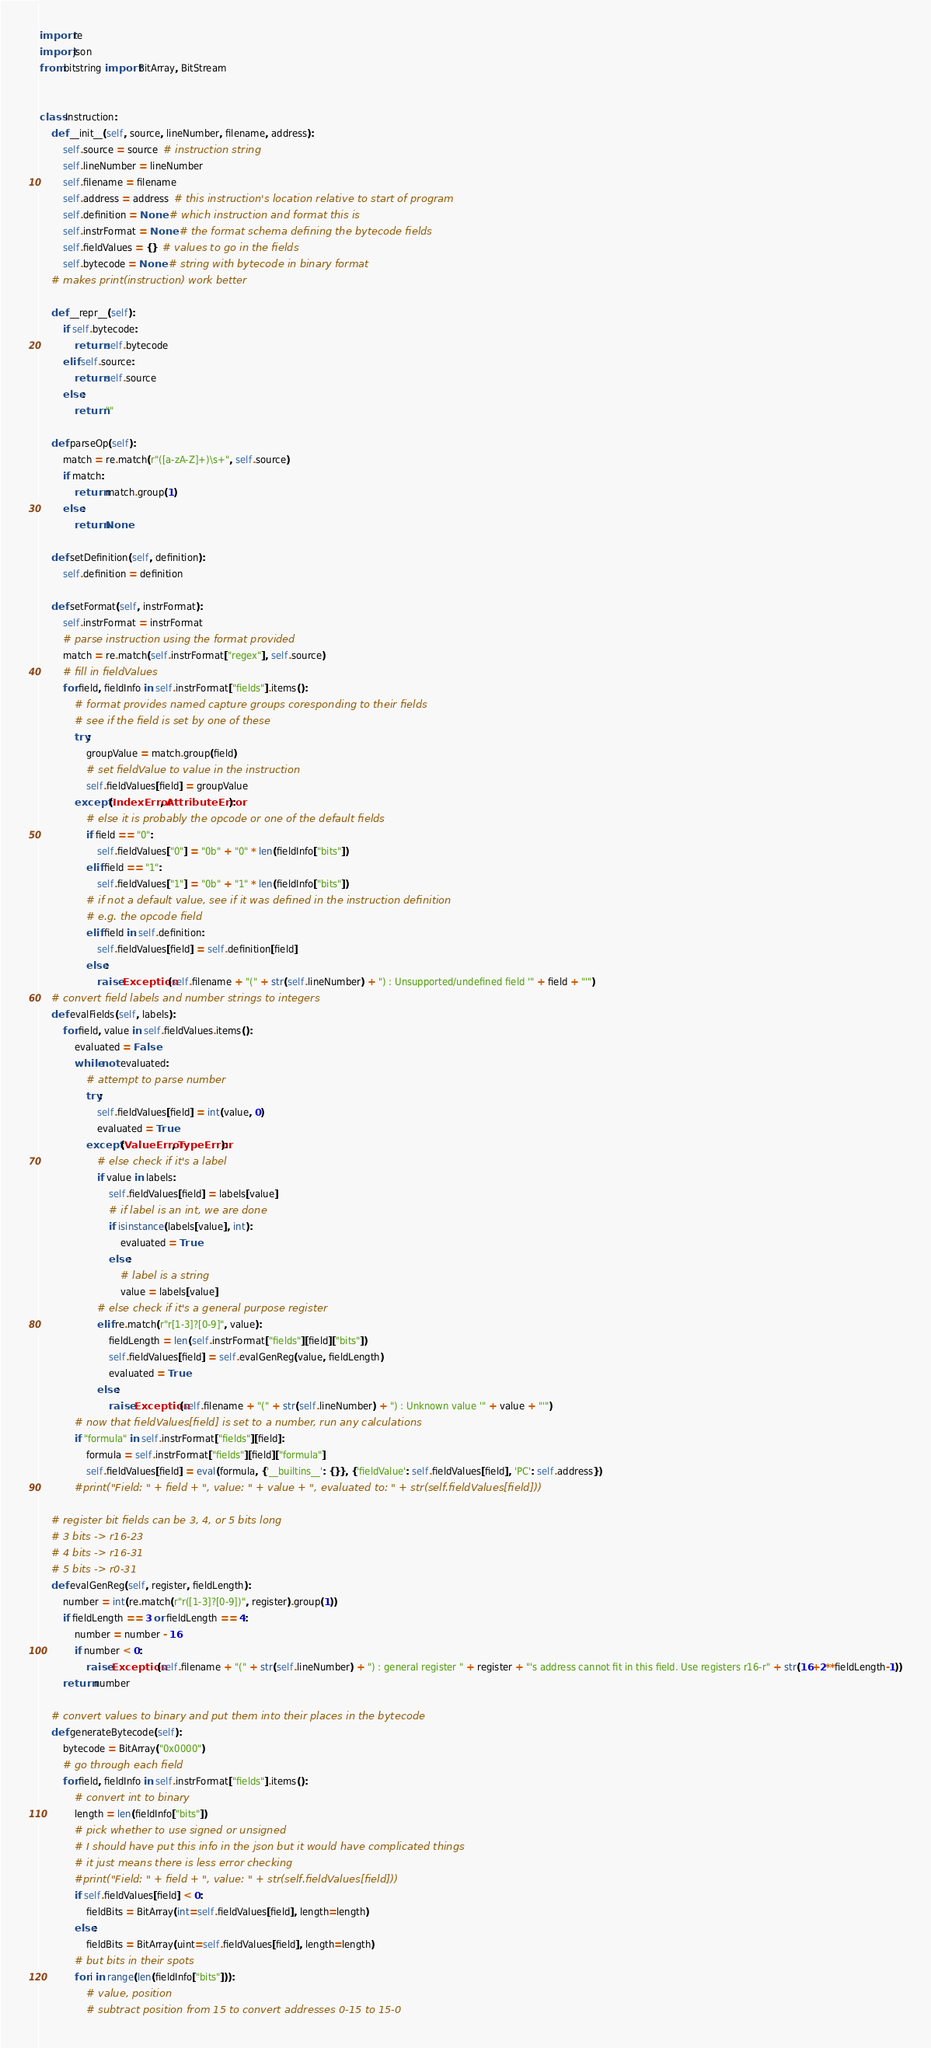<code> <loc_0><loc_0><loc_500><loc_500><_Python_>import re
import json
from bitstring import BitArray, BitStream


class Instruction:
    def __init__(self, source, lineNumber, filename, address):
        self.source = source  # instruction string
        self.lineNumber = lineNumber
        self.filename = filename
        self.address = address  # this instruction's location relative to start of program
        self.definition = None  # which instruction and format this is
        self.instrFormat = None  # the format schema defining the bytecode fields
        self.fieldValues = {}  # values to go in the fields
        self.bytecode = None  # string with bytecode in binary format
    # makes print(instruction) work better

    def __repr__(self):
        if self.bytecode:
            return self.bytecode
        elif self.source:
            return self.source
        else:
            return ""

    def parseOp(self):
        match = re.match(r"([a-zA-Z]+)\s+", self.source)
        if match:
            return match.group(1)
        else:
            return None

    def setDefinition(self, definition):
        self.definition = definition

    def setFormat(self, instrFormat):
        self.instrFormat = instrFormat
        # parse instruction using the format provided
        match = re.match(self.instrFormat["regex"], self.source)
        # fill in fieldValues
        for field, fieldInfo in self.instrFormat["fields"].items():
            # format provides named capture groups coresponding to their fields
            # see if the field is set by one of these
            try:
                groupValue = match.group(field)
                # set fieldValue to value in the instruction
                self.fieldValues[field] = groupValue
            except (IndexError, AttributeError):
                # else it is probably the opcode or one of the default fields
                if field == "0":
                    self.fieldValues["0"] = "0b" + "0" * len(fieldInfo["bits"])
                elif field == "1":
                    self.fieldValues["1"] = "0b" + "1" * len(fieldInfo["bits"])
                # if not a default value, see if it was defined in the instruction definition
                # e.g. the opcode field
                elif field in self.definition:
                    self.fieldValues[field] = self.definition[field]
                else:
                    raise Exception(self.filename + "(" + str(self.lineNumber) + ") : Unsupported/undefined field '" + field + "'")
    # convert field labels and number strings to integers
    def evalFields(self, labels):
        for field, value in self.fieldValues.items():
            evaluated = False
            while not evaluated:
                # attempt to parse number
                try:
                    self.fieldValues[field] = int(value, 0)
                    evaluated = True
                except (ValueError, TypeError):
                    # else check if it's a label
                    if value in labels:
                        self.fieldValues[field] = labels[value]
                        # if label is an int, we are done
                        if isinstance(labels[value], int):
                            evaluated = True
                        else:
                            # label is a string
                            value = labels[value]
                    # else check if it's a general purpose register
                    elif re.match(r"r[1-3]?[0-9]", value):
                        fieldLength = len(self.instrFormat["fields"][field]["bits"])
                        self.fieldValues[field] = self.evalGenReg(value, fieldLength)
                        evaluated = True
                    else:
                        raise Exception(self.filename + "(" + str(self.lineNumber) + ") : Unknown value '" + value + "'")
            # now that fieldValues[field] is set to a number, run any calculations
            if "formula" in self.instrFormat["fields"][field]:
                formula = self.instrFormat["fields"][field]["formula"]
                self.fieldValues[field] = eval(formula, {'__builtins__': {}}, {'fieldValue': self.fieldValues[field], 'PC': self.address})
            #print("Field: " + field + ", value: " + value + ", evaluated to: " + str(self.fieldValues[field]))

    # register bit fields can be 3, 4, or 5 bits long
    # 3 bits -> r16-23
    # 4 bits -> r16-31
    # 5 bits -> r0-31
    def evalGenReg(self, register, fieldLength):
        number = int(re.match(r"r([1-3]?[0-9])", register).group(1))
        if fieldLength == 3 or fieldLength == 4:
            number = number - 16
            if number < 0:
                raise Exception(self.filename + "(" + str(self.lineNumber) + ") : general register " + register + "'s address cannot fit in this field. Use registers r16-r" + str(16+2**fieldLength-1))
        return number

    # convert values to binary and put them into their places in the bytecode
    def generateBytecode(self):
        bytecode = BitArray("0x0000")
        # go through each field
        for field, fieldInfo in self.instrFormat["fields"].items():
            # convert int to binary
            length = len(fieldInfo["bits"])
            # pick whether to use signed or unsigned
            # I should have put this info in the json but it would have complicated things
            # it just means there is less error checking
            #print("Field: " + field + ", value: " + str(self.fieldValues[field]))
            if self.fieldValues[field] < 0:
                fieldBits = BitArray(int=self.fieldValues[field], length=length)
            else:
                fieldBits = BitArray(uint=self.fieldValues[field], length=length)
            # but bits in their spots
            for i in range(len(fieldInfo["bits"])):
                # value, position
                # subtract position from 15 to convert addresses 0-15 to 15-0</code> 